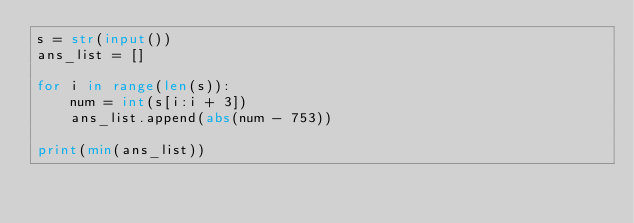Convert code to text. <code><loc_0><loc_0><loc_500><loc_500><_Python_>s = str(input())
ans_list = []

for i in range(len(s)):
    num = int(s[i:i + 3])
    ans_list.append(abs(num - 753))

print(min(ans_list))</code> 